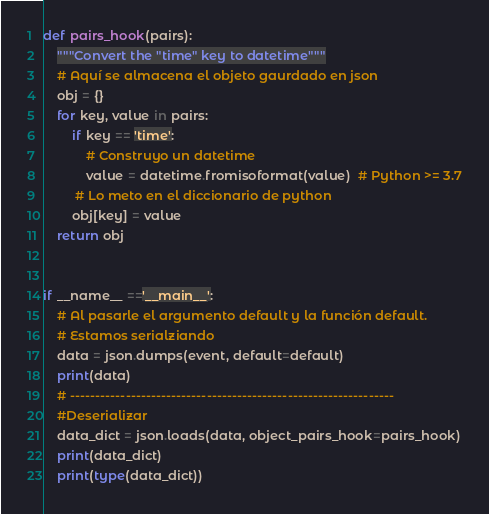Convert code to text. <code><loc_0><loc_0><loc_500><loc_500><_Python_>
def pairs_hook(pairs):
    """Convert the "time" key to datetime"""
    # Aquí se almacena el objeto gaurdado en json
    obj = {}
    for key, value in pairs:
        if key == 'time':
            # Construyo un datetime
            value = datetime.fromisoformat(value)  # Python >= 3.7
         # Lo meto en el diccionario de python   
        obj[key] = value
    return obj


if __name__ =='__main__':
    # Al pasarle el argumento default y la función default.
    # Estamos serialziando
    data = json.dumps(event, default=default)
    print(data)
    # ----------------------------------------------------------------
    #Deserializar
    data_dict = json.loads(data, object_pairs_hook=pairs_hook)
    print(data_dict)
    print(type(data_dict))

</code> 